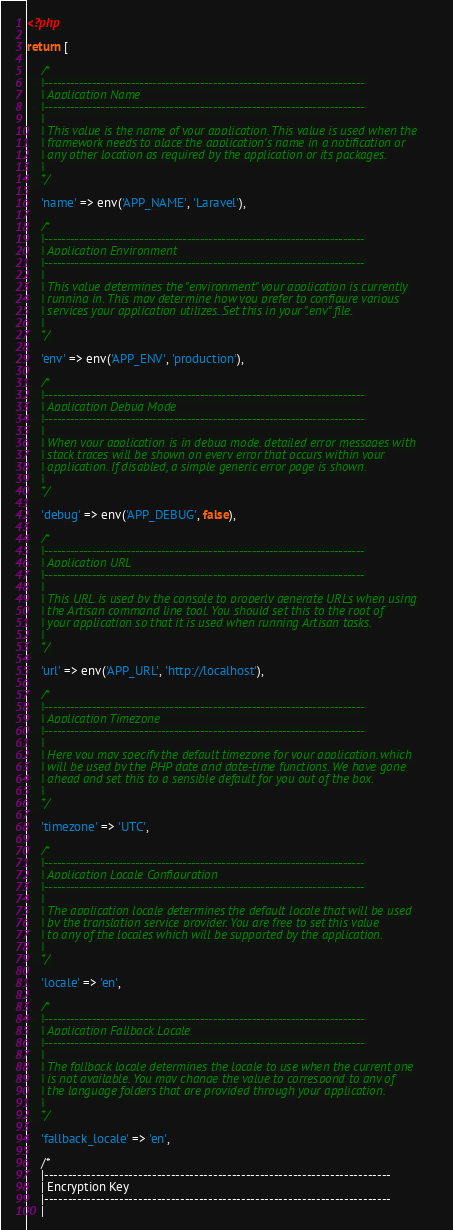Convert code to text. <code><loc_0><loc_0><loc_500><loc_500><_PHP_><?php

return [

    /*
    |--------------------------------------------------------------------------
    | Application Name
    |--------------------------------------------------------------------------
    |
    | This value is the name of your application. This value is used when the
    | framework needs to place the application's name in a notification or
    | any other location as required by the application or its packages.
    |
    */

    'name' => env('APP_NAME', 'Laravel'),

    /*
    |--------------------------------------------------------------------------
    | Application Environment
    |--------------------------------------------------------------------------
    |
    | This value determines the "environment" your application is currently
    | running in. This may determine how you prefer to configure various
    | services your application utilizes. Set this in your ".env" file.
    |
    */

    'env' => env('APP_ENV', 'production'),

    /*
    |--------------------------------------------------------------------------
    | Application Debug Mode
    |--------------------------------------------------------------------------
    |
    | When your application is in debug mode, detailed error messages with
    | stack traces will be shown on every error that occurs within your
    | application. If disabled, a simple generic error page is shown.
    |
    */

    'debug' => env('APP_DEBUG', false),

    /*
    |--------------------------------------------------------------------------
    | Application URL
    |--------------------------------------------------------------------------
    |
    | This URL is used by the console to properly generate URLs when using
    | the Artisan command line tool. You should set this to the root of
    | your application so that it is used when running Artisan tasks.
    |
    */

    'url' => env('APP_URL', 'http://localhost'),

    /*
    |--------------------------------------------------------------------------
    | Application Timezone
    |--------------------------------------------------------------------------
    |
    | Here you may specify the default timezone for your application, which
    | will be used by the PHP date and date-time functions. We have gone
    | ahead and set this to a sensible default for you out of the box.
    |
    */

    'timezone' => 'UTC',

    /*
    |--------------------------------------------------------------------------
    | Application Locale Configuration
    |--------------------------------------------------------------------------
    |
    | The application locale determines the default locale that will be used
    | by the translation service provider. You are free to set this value
    | to any of the locales which will be supported by the application.
    |
    */

    'locale' => 'en',

    /*
    |--------------------------------------------------------------------------
    | Application Fallback Locale
    |--------------------------------------------------------------------------
    |
    | The fallback locale determines the locale to use when the current one
    | is not available. You may change the value to correspond to any of
    | the language folders that are provided through your application.
    |
    */

    'fallback_locale' => 'en',

    /*
    |--------------------------------------------------------------------------
    | Encryption Key
    |--------------------------------------------------------------------------
    |</code> 